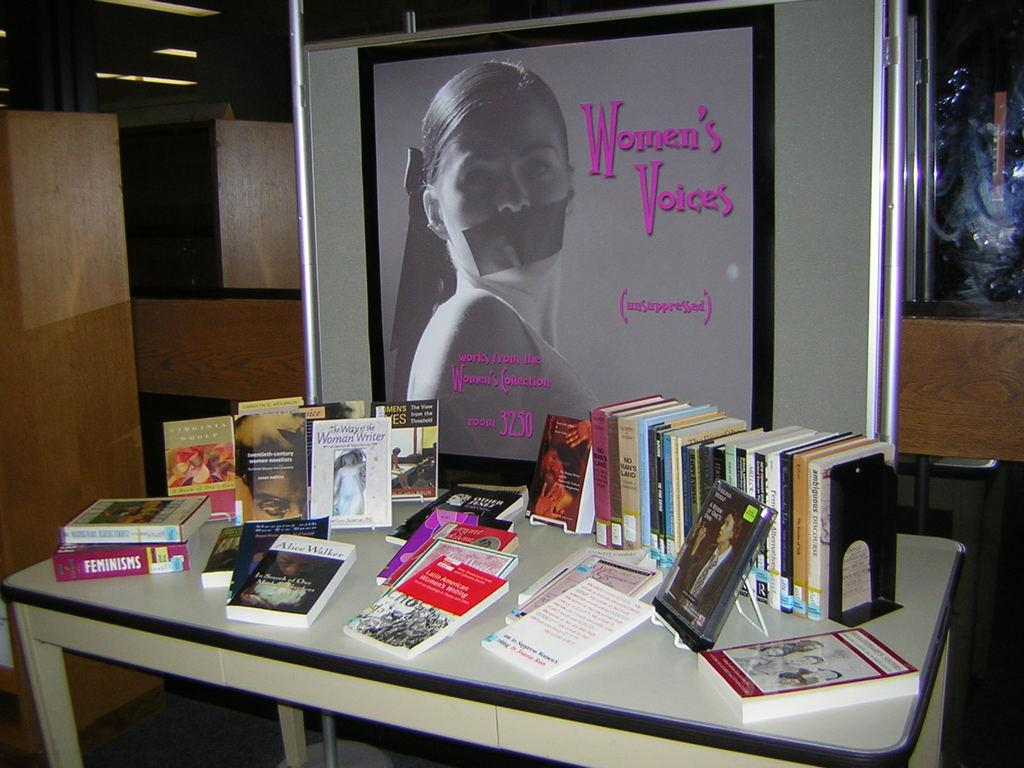Provide a one-sentence caption for the provided image. A white desk filled with book piles and a picture frame that reads Women's  Voices. 